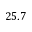Convert formula to latex. <formula><loc_0><loc_0><loc_500><loc_500>2 5 . 7</formula> 